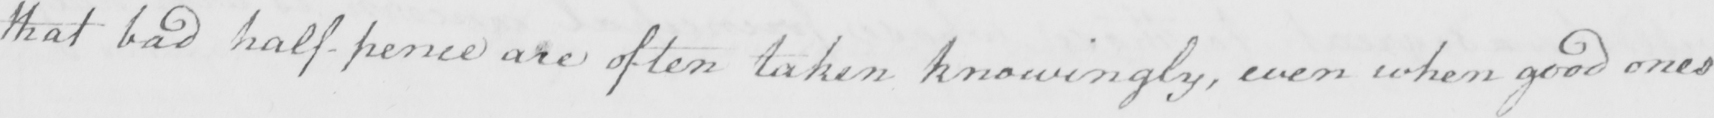What is written in this line of handwriting? that bad half-pence are often taken knowingly , even when good ones 